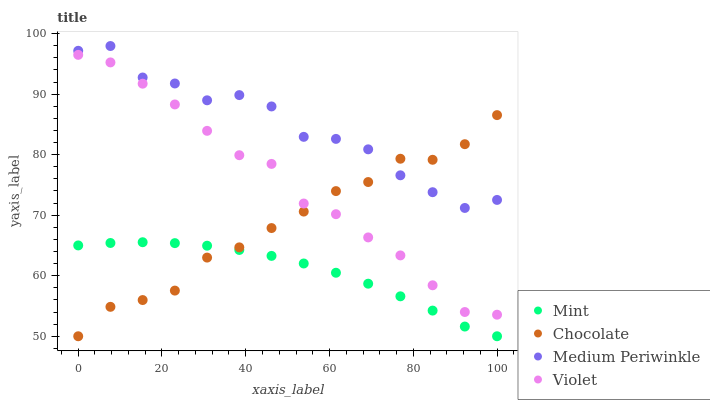Does Mint have the minimum area under the curve?
Answer yes or no. Yes. Does Medium Periwinkle have the maximum area under the curve?
Answer yes or no. Yes. Does Violet have the minimum area under the curve?
Answer yes or no. No. Does Violet have the maximum area under the curve?
Answer yes or no. No. Is Mint the smoothest?
Answer yes or no. Yes. Is Medium Periwinkle the roughest?
Answer yes or no. Yes. Is Violet the smoothest?
Answer yes or no. No. Is Violet the roughest?
Answer yes or no. No. Does Mint have the lowest value?
Answer yes or no. Yes. Does Violet have the lowest value?
Answer yes or no. No. Does Medium Periwinkle have the highest value?
Answer yes or no. Yes. Does Violet have the highest value?
Answer yes or no. No. Is Violet less than Medium Periwinkle?
Answer yes or no. Yes. Is Medium Periwinkle greater than Mint?
Answer yes or no. Yes. Does Chocolate intersect Violet?
Answer yes or no. Yes. Is Chocolate less than Violet?
Answer yes or no. No. Is Chocolate greater than Violet?
Answer yes or no. No. Does Violet intersect Medium Periwinkle?
Answer yes or no. No. 